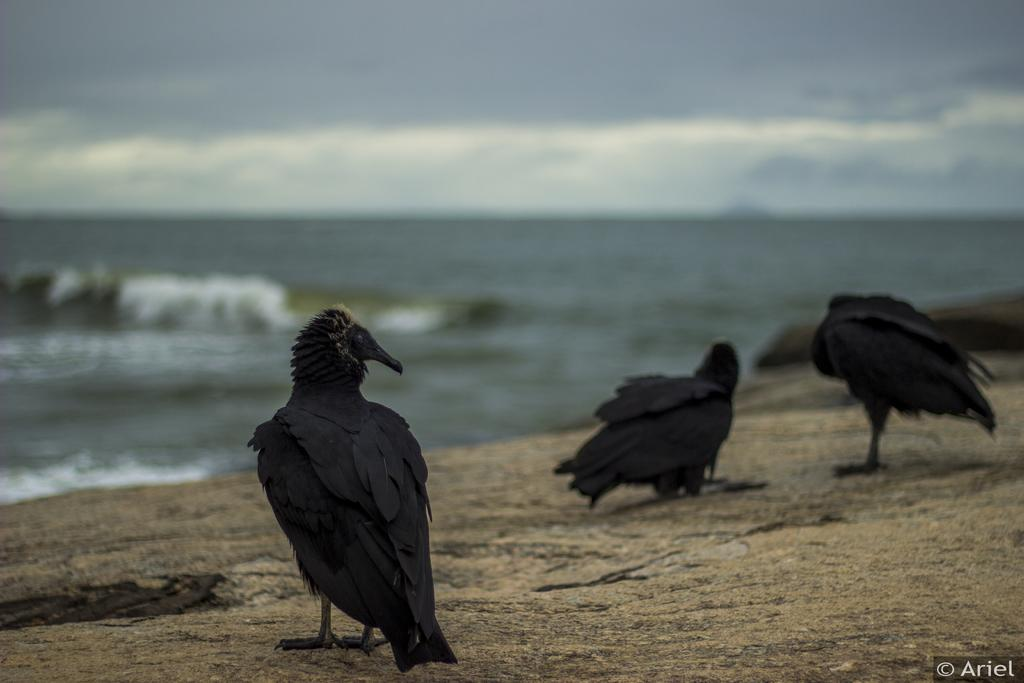What type of animals can be seen in the image? There are birds in the image. What can be seen in the sky in the image? There are clouds visible in the sky. What type of natural feature is present in the image? There is a sea in the image. What type of shoes can be seen floating in the sea in the image? There are no shoes present in the image; it features birds and clouds in the sky above a sea. 